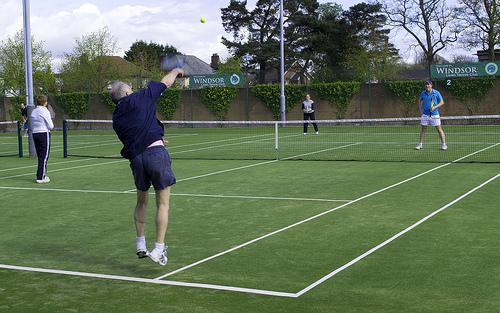Question: what game is being played?
Choices:
A. Basketball.
B. Tennis.
C. Soccer.
D. Racquetball.
Answer with the letter. Answer: B Question: where was the photo taken?
Choices:
A. Tennis court.
B. Basketball court.
C. Football field.
D. Street.
Answer with the letter. Answer: A Question: who is playing tennis?
Choices:
A. A boy.
B. A girl.
C. Men and women.
D. Children.
Answer with the letter. Answer: C Question: what color are the field lines?
Choices:
A. White.
B. Yellow.
C. Red.
D. Blue.
Answer with the letter. Answer: A 